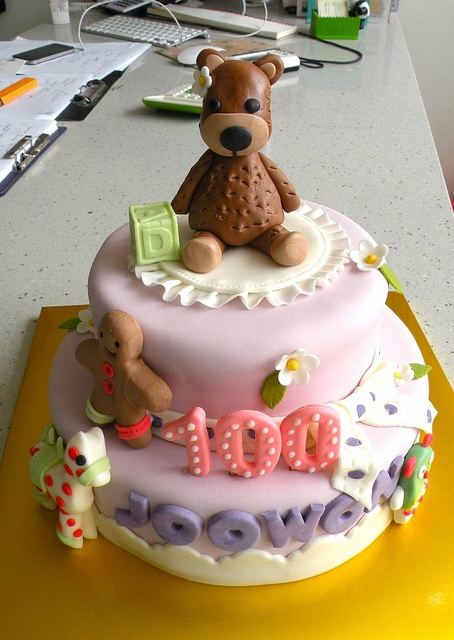Describe the objects in this image and their specific colors. I can see cake in black, white, brown, darkgray, and maroon tones, keyboard in black, darkgray, gray, and lightgray tones, cell phone in black, darkgray, gray, and purple tones, cell phone in black, white, darkgray, and gray tones, and mouse in black, darkgray, lightgray, and gray tones in this image. 